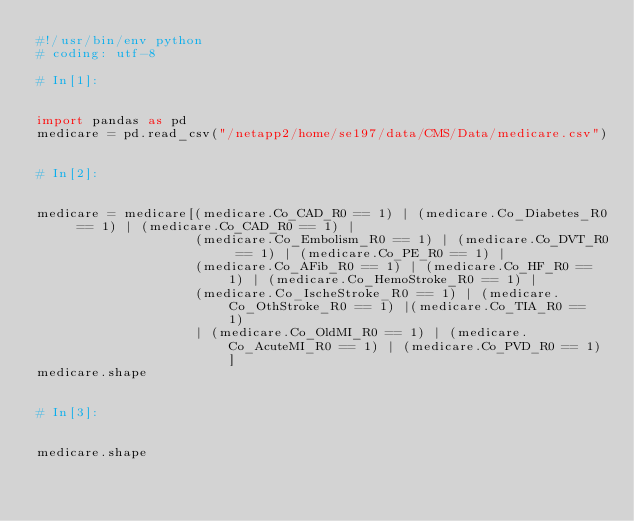<code> <loc_0><loc_0><loc_500><loc_500><_Python_>#!/usr/bin/env python
# coding: utf-8

# In[1]:


import pandas as pd
medicare = pd.read_csv("/netapp2/home/se197/data/CMS/Data/medicare.csv")


# In[2]:


medicare = medicare[(medicare.Co_CAD_R0 == 1) | (medicare.Co_Diabetes_R0 == 1) | (medicare.Co_CAD_R0 == 1) | 
                    (medicare.Co_Embolism_R0 == 1) | (medicare.Co_DVT_R0 == 1) | (medicare.Co_PE_R0 == 1) | 
                    (medicare.Co_AFib_R0 == 1) | (medicare.Co_HF_R0 == 1) | (medicare.Co_HemoStroke_R0 == 1) | 
                    (medicare.Co_IscheStroke_R0 == 1) | (medicare.Co_OthStroke_R0 == 1) |(medicare.Co_TIA_R0 == 1)
                    | (medicare.Co_OldMI_R0 == 1) | (medicare.Co_AcuteMI_R0 == 1) | (medicare.Co_PVD_R0 == 1)]
medicare.shape


# In[3]:


medicare.shape

</code> 